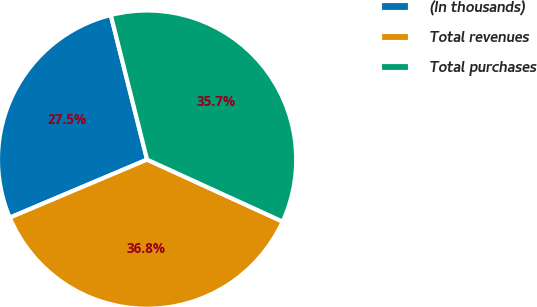<chart> <loc_0><loc_0><loc_500><loc_500><pie_chart><fcel>(In thousands)<fcel>Total revenues<fcel>Total purchases<nl><fcel>27.45%<fcel>36.81%<fcel>35.74%<nl></chart> 